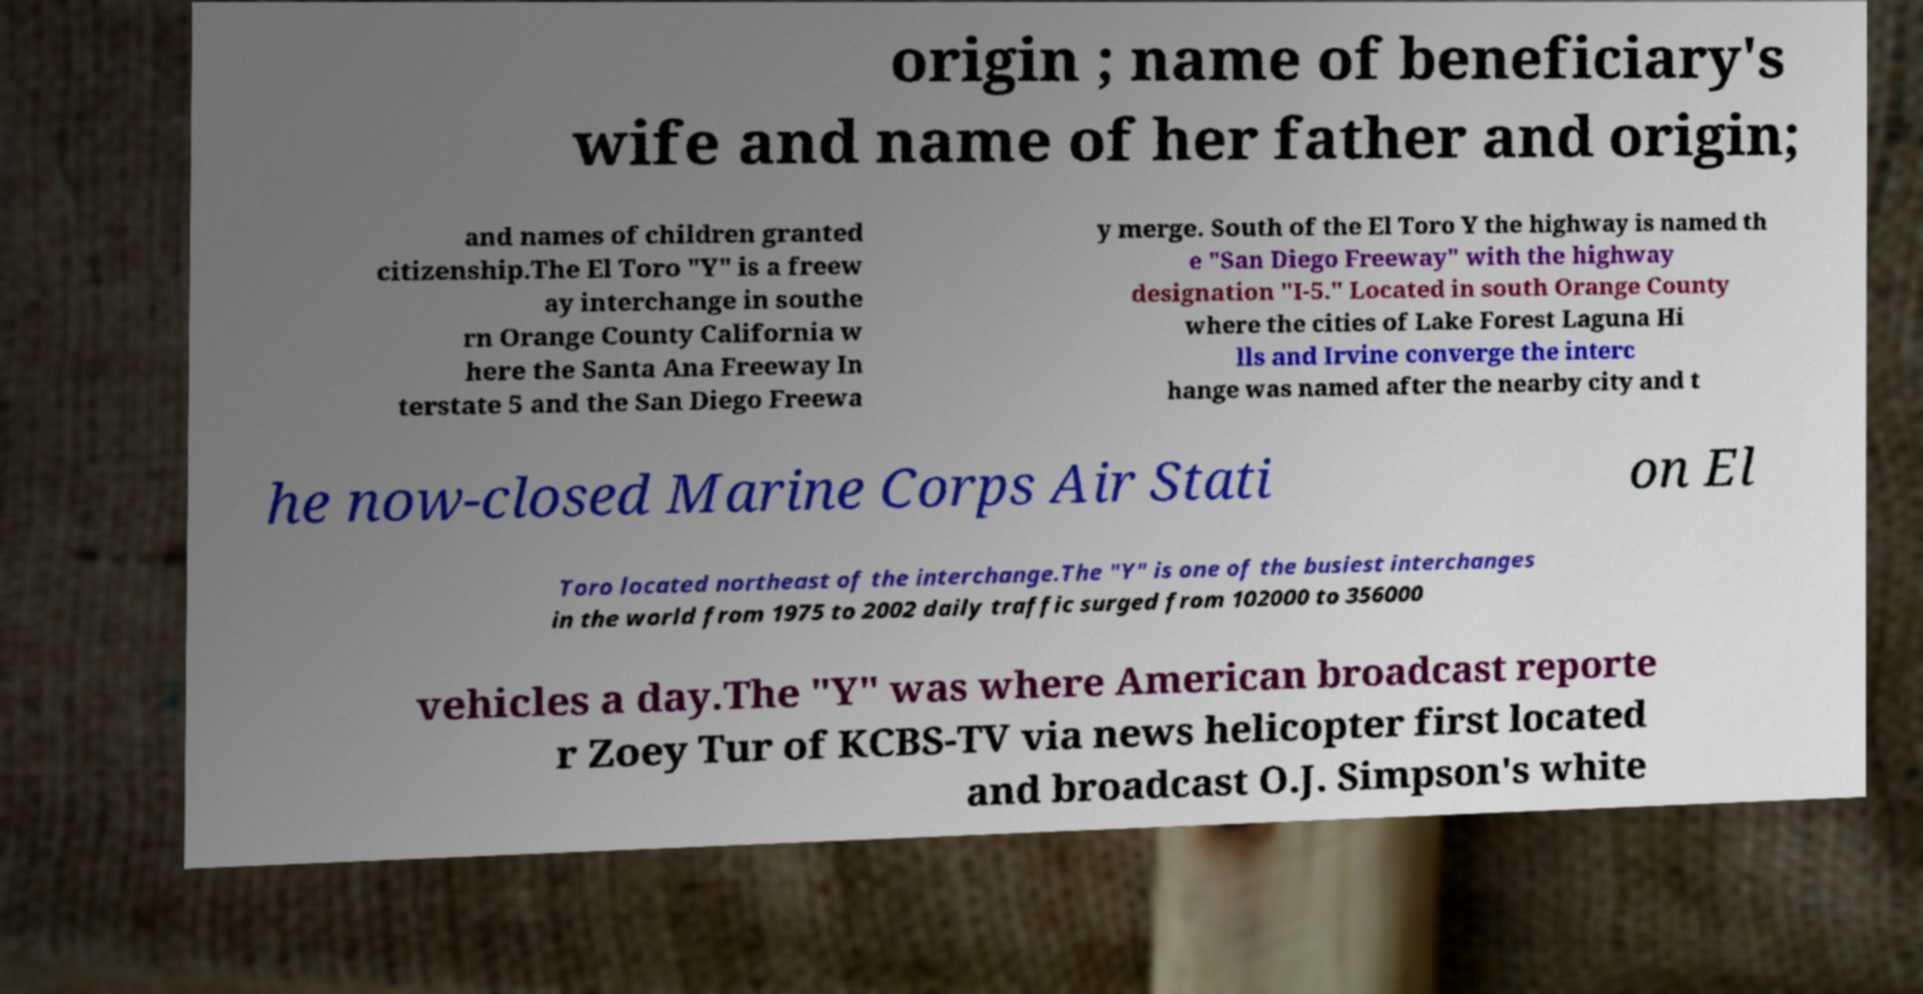Could you assist in decoding the text presented in this image and type it out clearly? origin ; name of beneficiary's wife and name of her father and origin; and names of children granted citizenship.The El Toro "Y" is a freew ay interchange in southe rn Orange County California w here the Santa Ana Freeway In terstate 5 and the San Diego Freewa y merge. South of the El Toro Y the highway is named th e "San Diego Freeway" with the highway designation "I-5." Located in south Orange County where the cities of Lake Forest Laguna Hi lls and Irvine converge the interc hange was named after the nearby city and t he now-closed Marine Corps Air Stati on El Toro located northeast of the interchange.The "Y" is one of the busiest interchanges in the world from 1975 to 2002 daily traffic surged from 102000 to 356000 vehicles a day.The "Y" was where American broadcast reporte r Zoey Tur of KCBS-TV via news helicopter first located and broadcast O.J. Simpson's white 